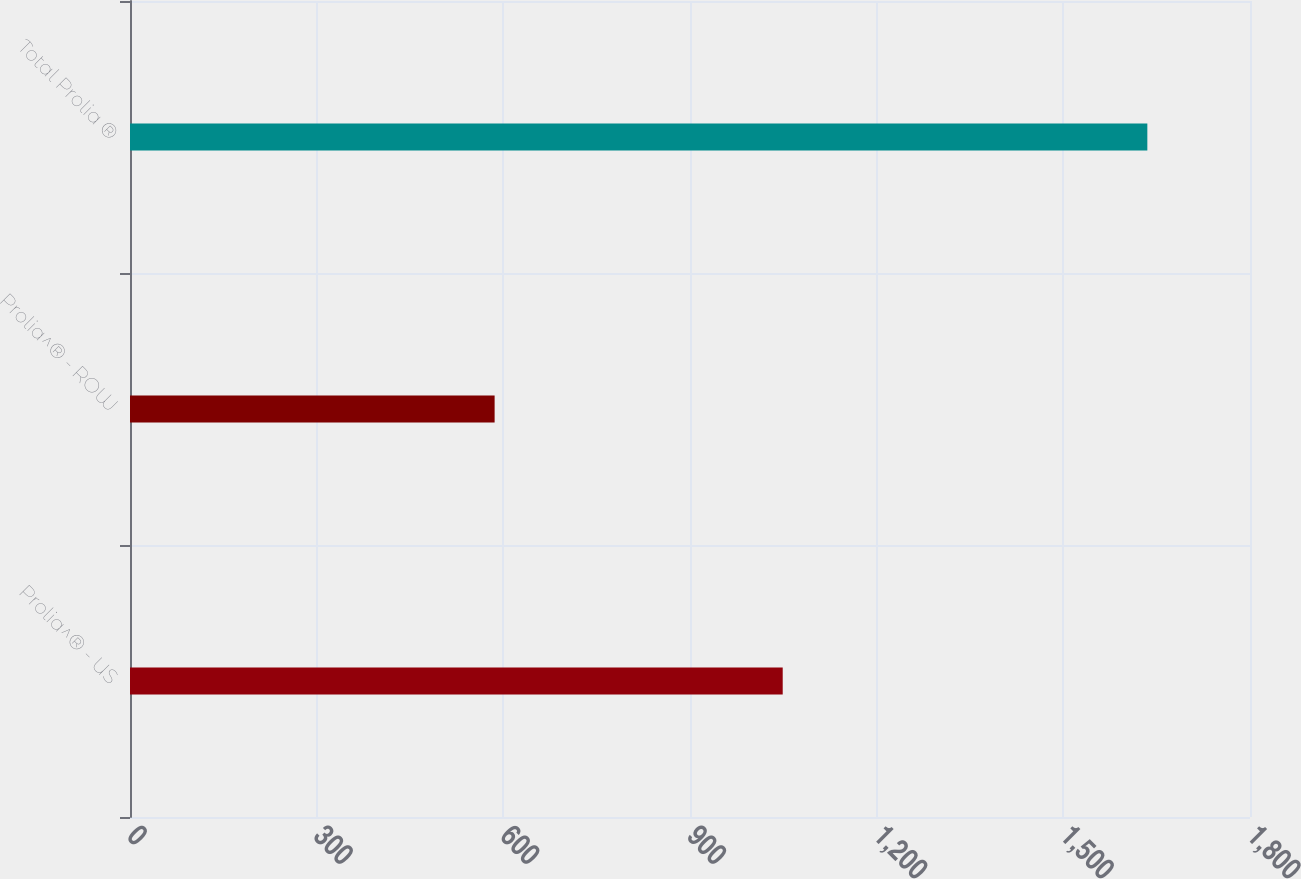Convert chart to OTSL. <chart><loc_0><loc_0><loc_500><loc_500><bar_chart><fcel>Prolia^® - US<fcel>Prolia^® - ROW<fcel>Total Prolia ®<nl><fcel>1049<fcel>586<fcel>1635<nl></chart> 